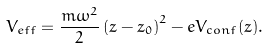<formula> <loc_0><loc_0><loc_500><loc_500>V _ { e f f } = \frac { m \omega ^ { 2 } } { 2 } \left ( z - z _ { 0 } \right ) ^ { 2 } - e V _ { c o n f } ( z ) .</formula> 